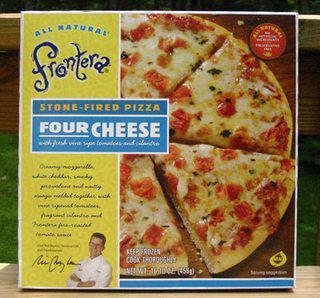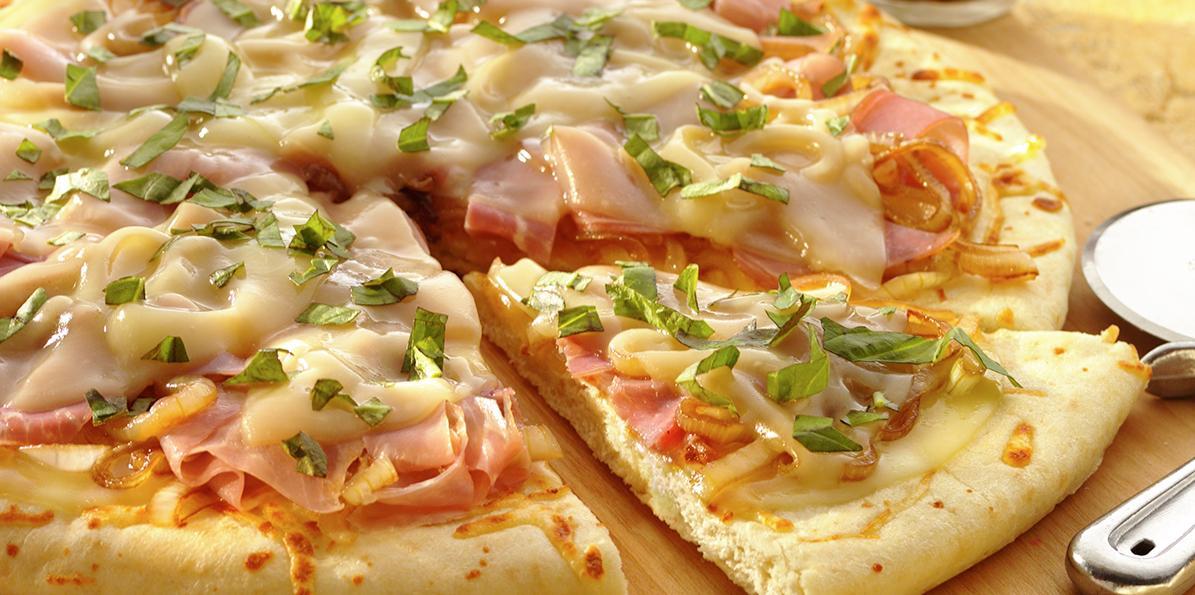The first image is the image on the left, the second image is the image on the right. Assess this claim about the two images: "There is a pizza cutter in the right image.". Correct or not? Answer yes or no. Yes. 